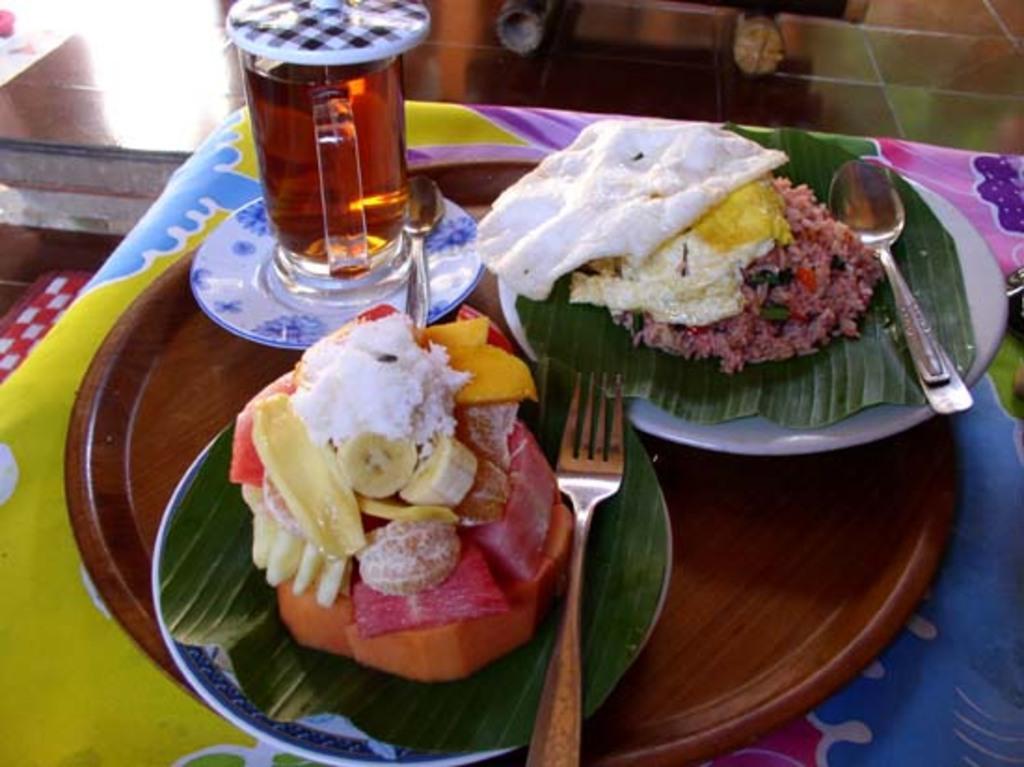Describe this image in one or two sentences. In this image I can see few food items, spoons on the plates. I can see the glass on the white color plate. These are on the brown color plate. The brown color plate is on the colorful object. 